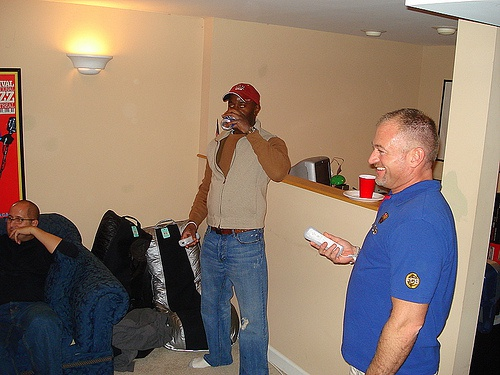Describe the objects in this image and their specific colors. I can see people in tan, blue, and salmon tones, people in tan, blue, and gray tones, people in tan, black, navy, maroon, and brown tones, couch in tan, black, navy, and blue tones, and tv in tan, black, gray, darkgray, and maroon tones in this image. 